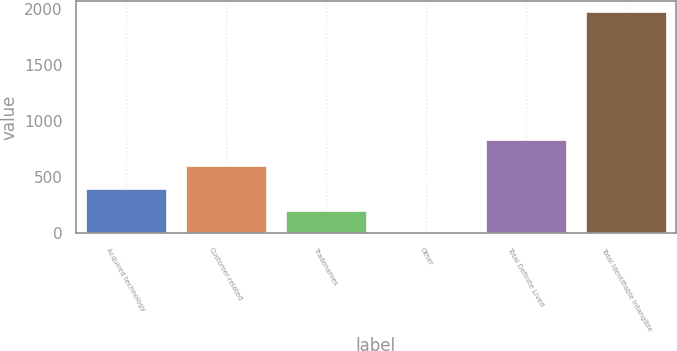Convert chart to OTSL. <chart><loc_0><loc_0><loc_500><loc_500><bar_chart><fcel>Acquired technology<fcel>Customer-related<fcel>Tradenames<fcel>Other<fcel>Total Definite Lived<fcel>Total Identifiable Intangible<nl><fcel>400<fcel>598<fcel>203.5<fcel>7<fcel>832<fcel>1972<nl></chart> 